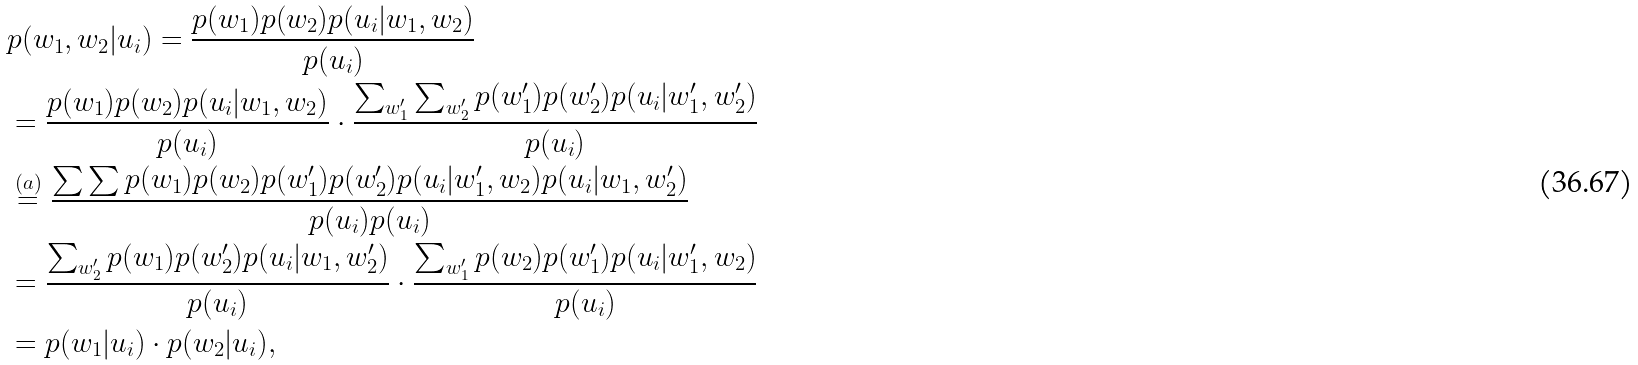<formula> <loc_0><loc_0><loc_500><loc_500>& p ( w _ { 1 } , w _ { 2 } | u _ { i } ) = \frac { p ( w _ { 1 } ) p ( w _ { 2 } ) p ( u _ { i } | w _ { 1 } , w _ { 2 } ) } { p ( u _ { i } ) } \\ & = \frac { p ( w _ { 1 } ) p ( w _ { 2 } ) p ( u _ { i } | w _ { 1 } , w _ { 2 } ) } { p ( u _ { i } ) } \cdot \frac { \sum _ { w _ { 1 } ^ { \prime } } \sum _ { w _ { 2 } ^ { \prime } } p ( w _ { 1 } ^ { \prime } ) p ( w _ { 2 } ^ { \prime } ) p ( u _ { i } | w _ { 1 } ^ { \prime } , w _ { 2 } ^ { \prime } ) } { p ( u _ { i } ) } \\ & \overset { ( a ) } { = } \frac { \sum \sum p ( w _ { 1 } ) p ( w _ { 2 } ) p ( w _ { 1 } ^ { \prime } ) p ( w _ { 2 } ^ { \prime } ) p ( u _ { i } | w _ { 1 } ^ { \prime } , w _ { 2 } ) p ( u _ { i } | w _ { 1 } , w _ { 2 } ^ { \prime } ) } { p ( u _ { i } ) p ( u _ { i } ) } \\ & = \frac { \sum _ { w _ { 2 } ^ { \prime } } p ( w _ { 1 } ) p ( w _ { 2 } ^ { \prime } ) p ( u _ { i } | w _ { 1 } , w _ { 2 } ^ { \prime } ) } { p ( u _ { i } ) } \cdot \frac { \sum _ { w _ { 1 } ^ { \prime } } p ( w _ { 2 } ) p ( w _ { 1 } ^ { \prime } ) p ( u _ { i } | w _ { 1 } ^ { \prime } , w _ { 2 } ) } { p ( u _ { i } ) } \\ & = p ( w _ { 1 } | u _ { i } ) \cdot p ( w _ { 2 } | u _ { i } ) ,</formula> 